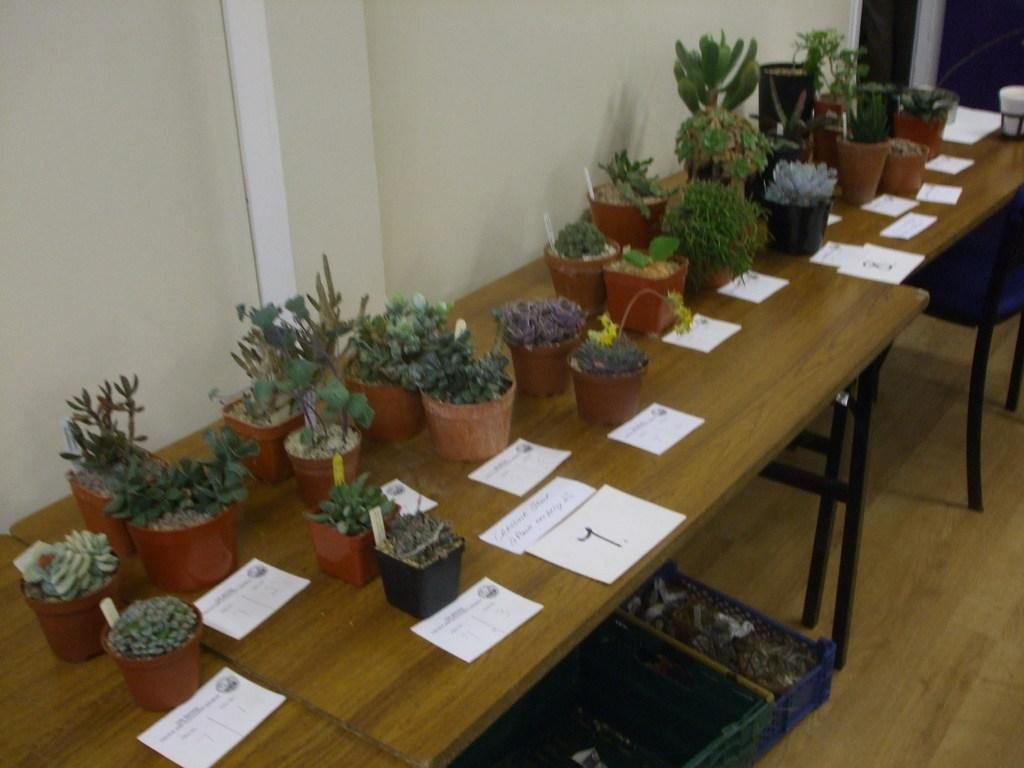What type of plants can be seen in the image? There are houseplants in the image. What objects are on the tables in the image? There are papers on the tables in the image. What type of containers are on the floor in the image? There are baskets on the floor in the image. What part of the room is visible in the image? The floor is visible in the image. Can you see a frog jumping on the houseplants in the image? There is no frog present in the image; it only features houseplants, papers, and baskets. What type of leaf is used as a utensil in the image? There is no leaf used as a utensil in the image; it only features houseplants, papers, and baskets. 